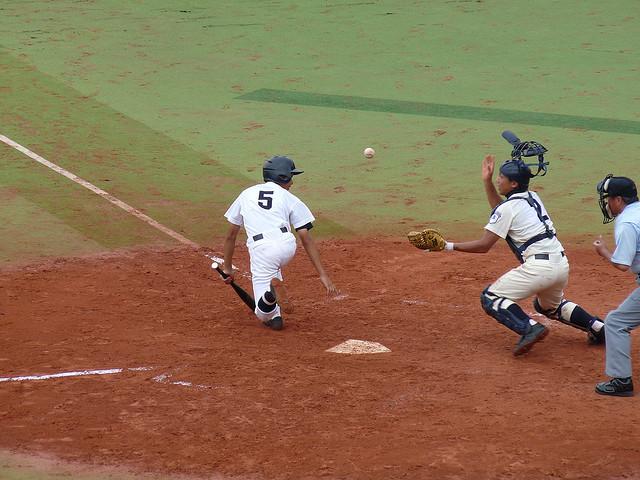What is he doing?
Concise answer only. Catching ball. Is the catcher going to catch the ball?
Answer briefly. Yes. Which sport is this?
Write a very short answer. Baseball. What is in the batters left hand?
Write a very short answer. Bat. Is the pitcher throwing a fastball?
Write a very short answer. Yes. What color is the glove?
Quick response, please. Brown. What color is the batter's shirt?
Write a very short answer. White. Is the batter in the correct spot?
Quick response, please. Yes. What is this sport?
Write a very short answer. Baseball. 